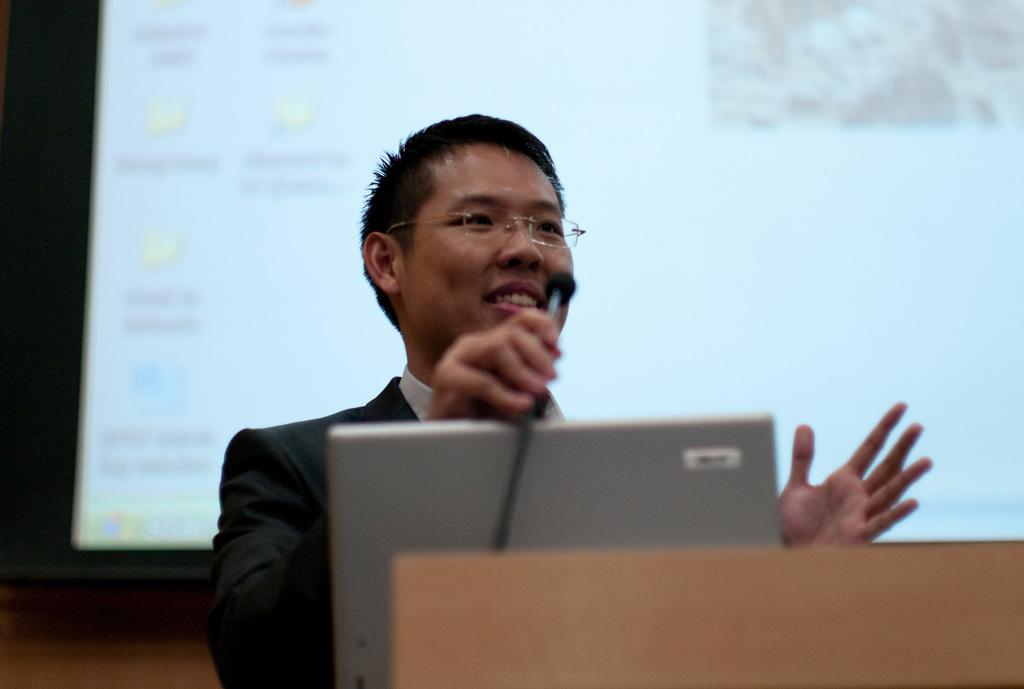Who is present in the image? There is a man in the image. What is the man's facial expression? The man is smiling. What accessory is the man wearing? The man is wearing spectacles. What objects are in front of the man? There is a laptop and a microphone in front of the man. What can be seen in the background of the image? There is a projector screen in the background of the image. What is the secretary doing in the image? There is no secretary present in the image. How does the man's pocket look in the image? There is no mention of the man's pocket in the provided facts, so it cannot be described. 